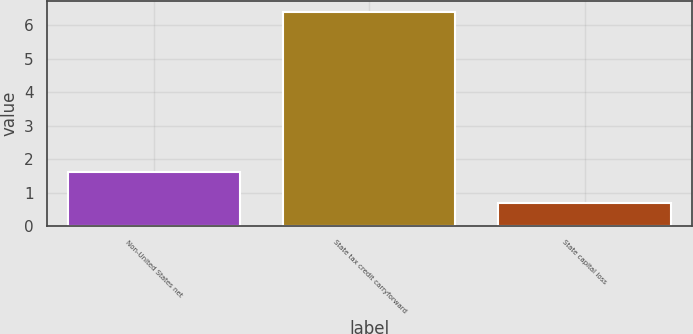Convert chart. <chart><loc_0><loc_0><loc_500><loc_500><bar_chart><fcel>Non-United States net<fcel>State tax credit carryforward<fcel>State capital loss<nl><fcel>1.6<fcel>6.4<fcel>0.7<nl></chart> 